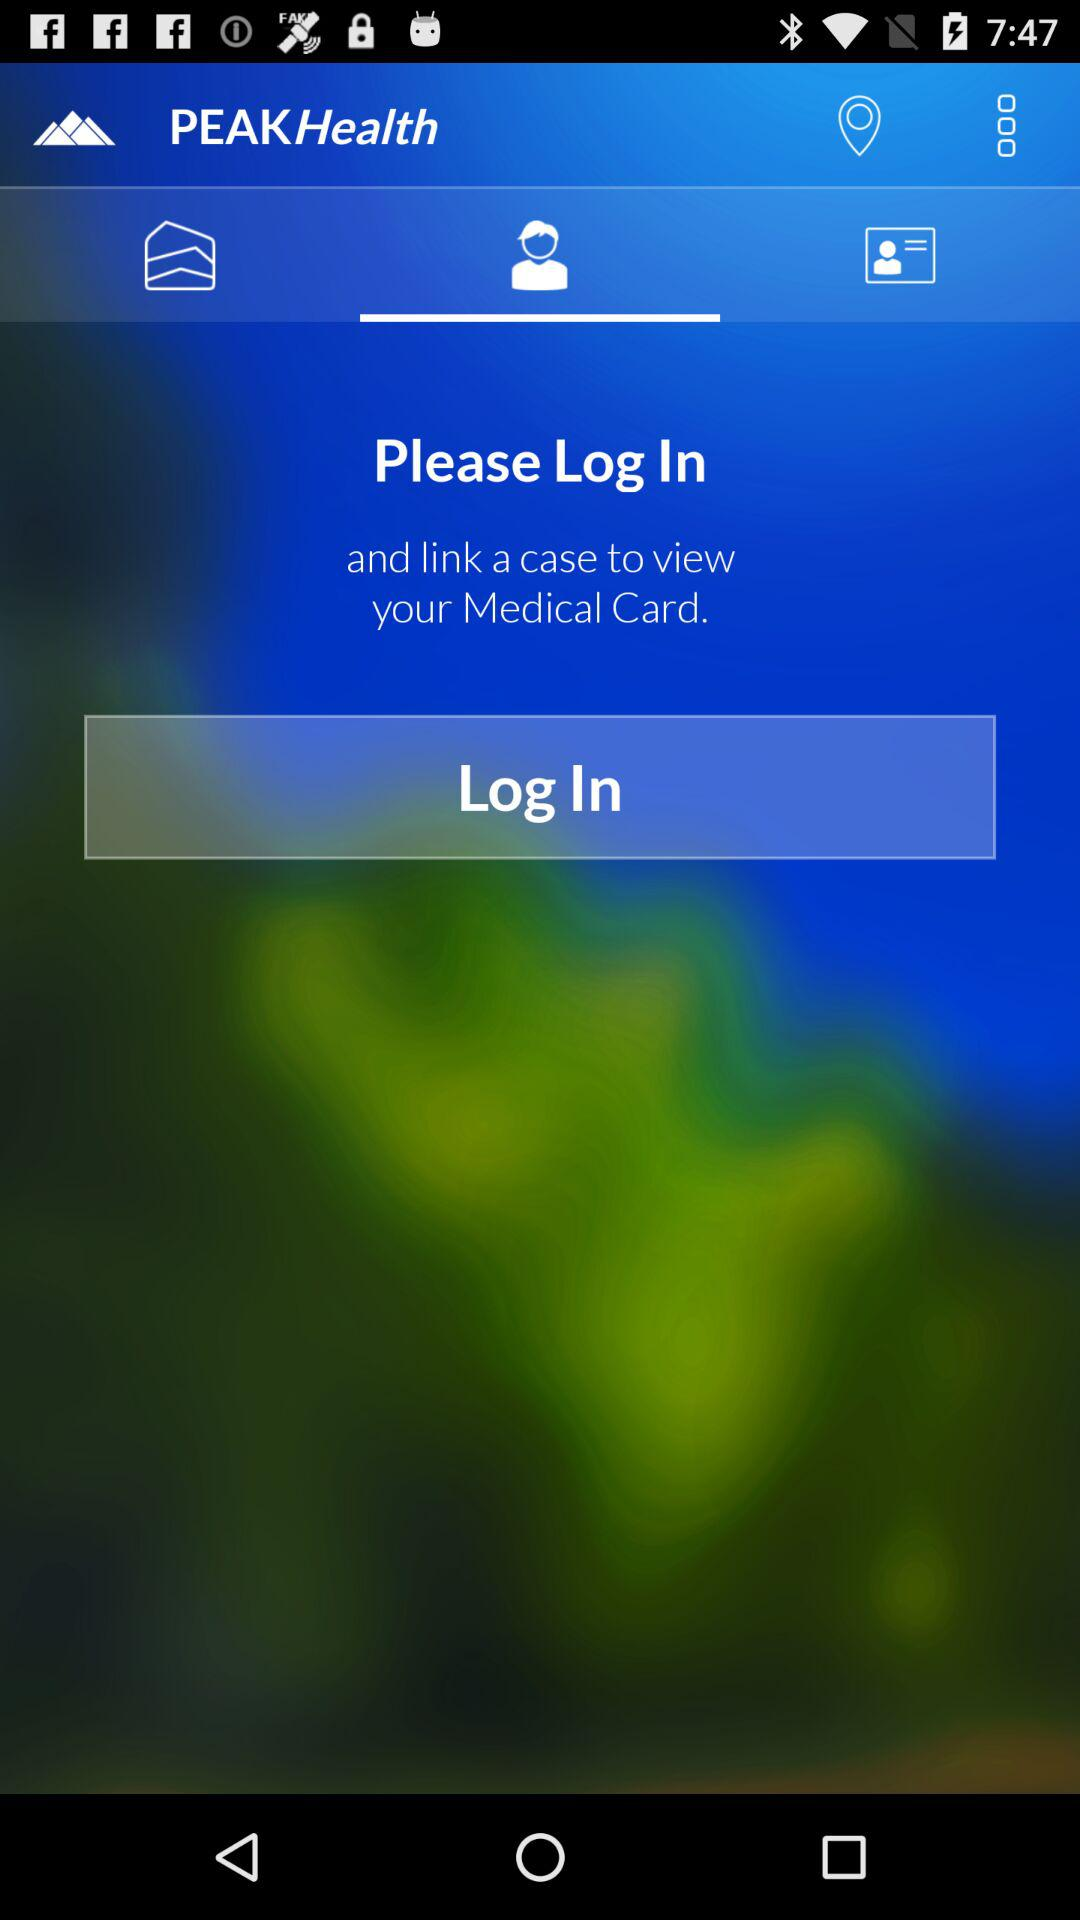Which tab is selected?
When the provided information is insufficient, respond with <no answer>. <no answer> 